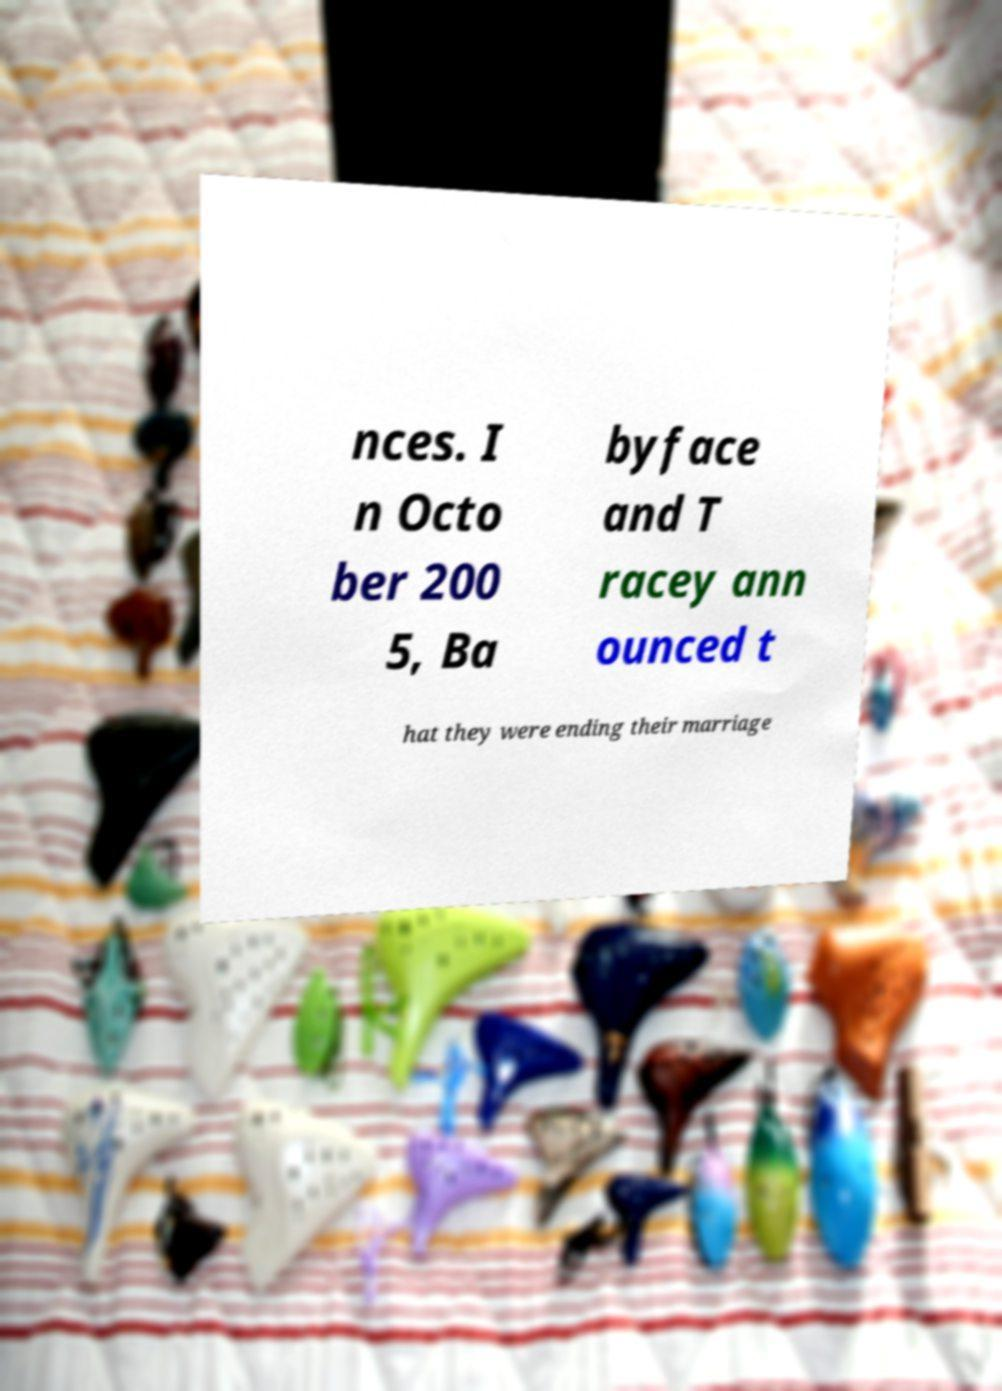Can you accurately transcribe the text from the provided image for me? nces. I n Octo ber 200 5, Ba byface and T racey ann ounced t hat they were ending their marriage 